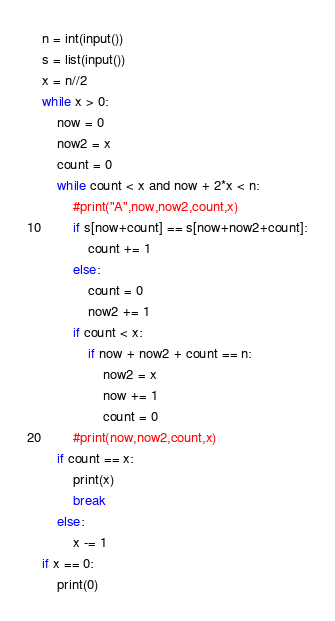<code> <loc_0><loc_0><loc_500><loc_500><_Python_>n = int(input())
s = list(input())
x = n//2
while x > 0:
    now = 0
    now2 = x
    count = 0
    while count < x and now + 2*x < n:
        #print("A",now,now2,count,x)
        if s[now+count] == s[now+now2+count]:
            count += 1
        else:
            count = 0
            now2 += 1
        if count < x:
            if now + now2 + count == n:
                now2 = x
                now += 1
                count = 0
        #print(now,now2,count,x)
    if count == x:
        print(x)
        break
    else:
        x -= 1
if x == 0:
    print(0)</code> 